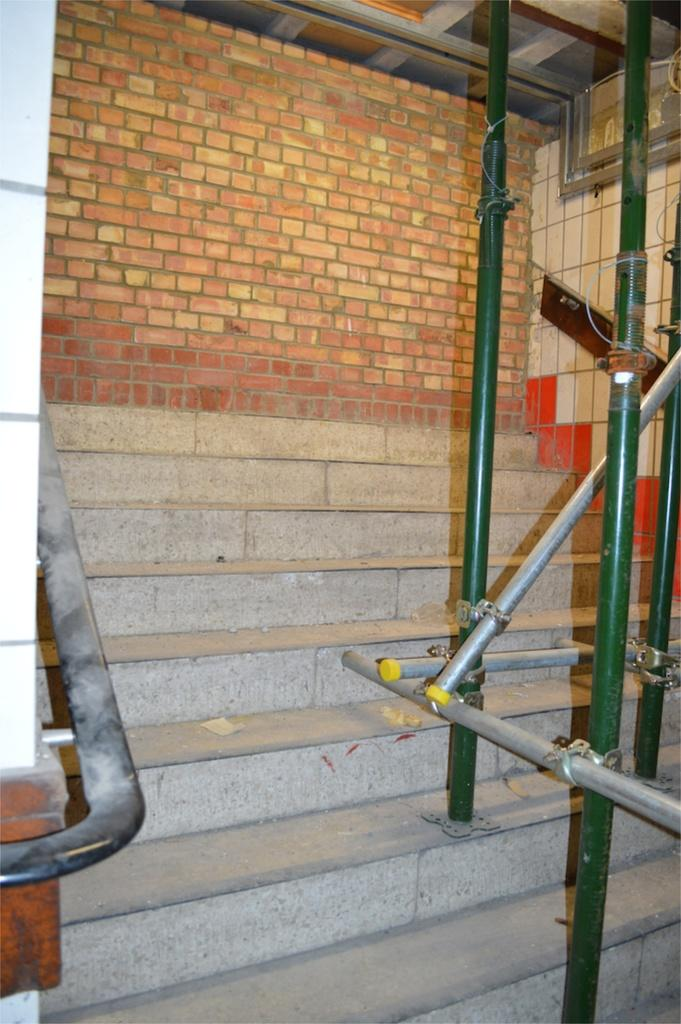What type of structure can be seen in the image? There are stairs in the image. What can be seen in the background of the image? There is a brick wall in the background of the image. What material are the rods visible in the image made of? The metal rods visible in the image are made of metal. What type of wave can be seen crashing against the stairs in the image? There is no wave present in the image; it features stairs, a brick wall, and metal rods. What type of nut is being used to secure the metal rods in the image? There is no nut visible in the image; it only shows metal rods. 